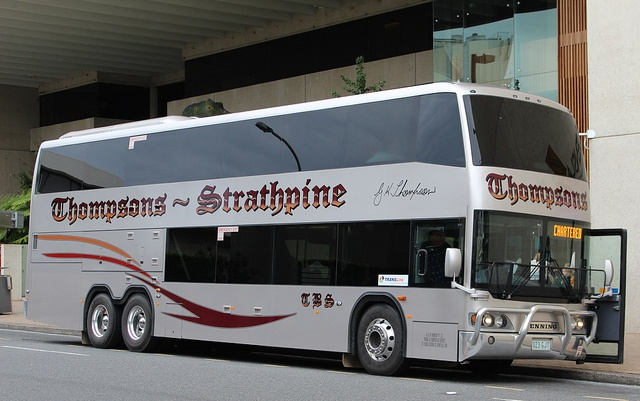Describe the objects in this image and their specific colors. I can see bus in gray, black, darkgray, and lightgray tones, people in gray, black, teal, and lightgray tones, and people in gray, darkgray, black, and lightgray tones in this image. 